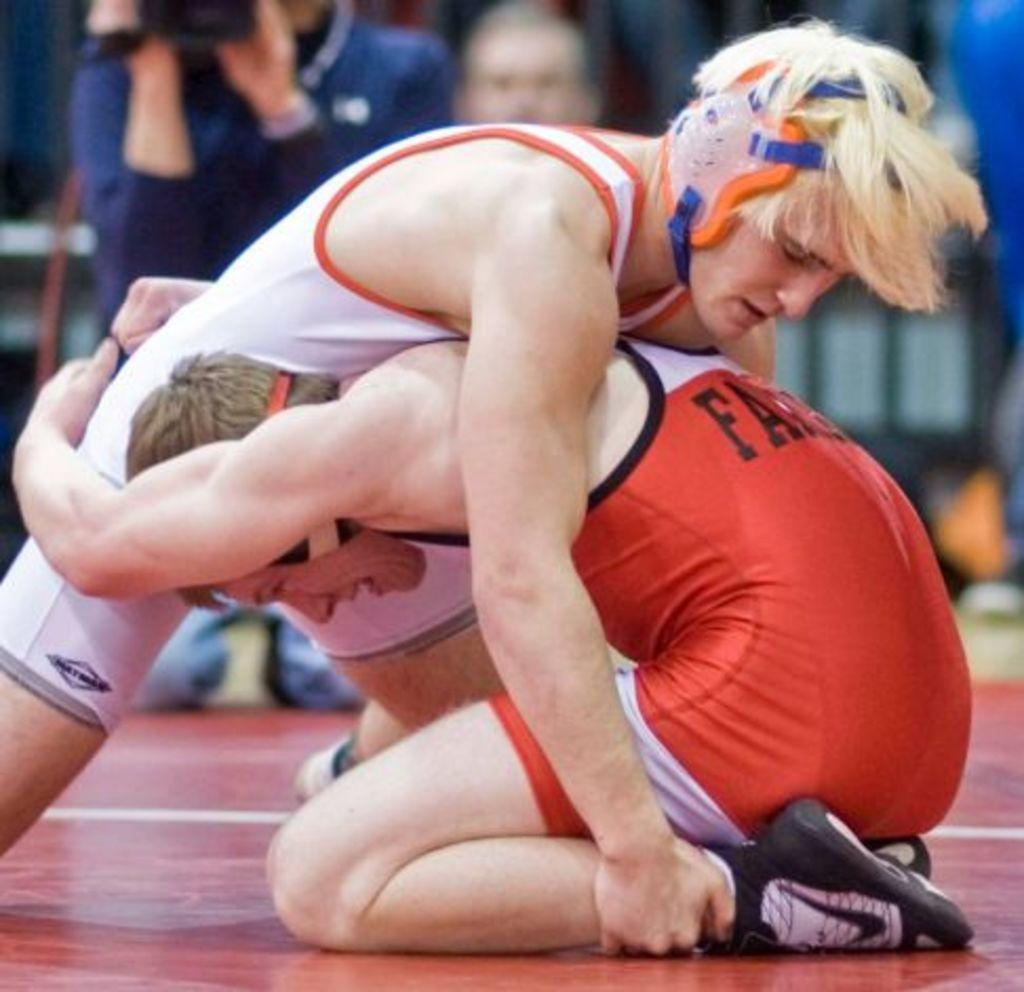Provide a one-sentence caption for the provided image. Two wrestlers wrestling, one with the letters FA written on the back. 